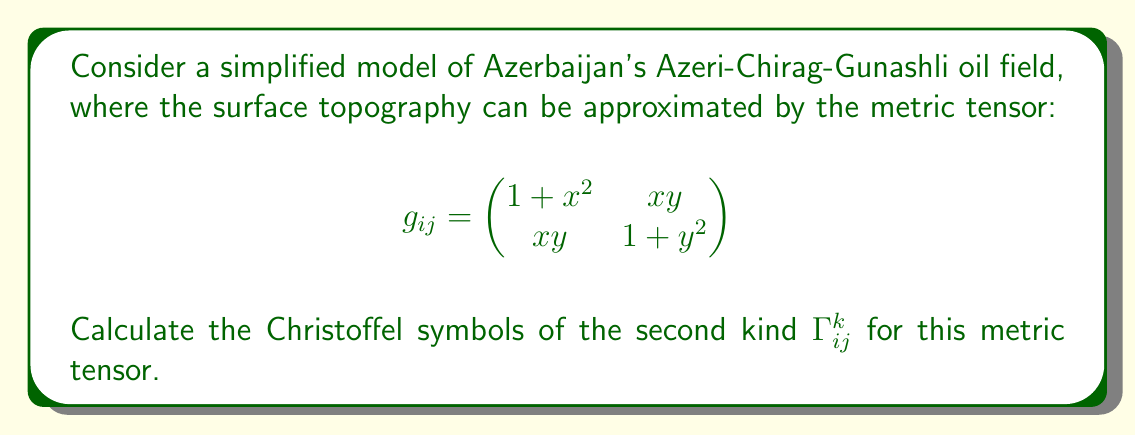Show me your answer to this math problem. To calculate the Christoffel symbols, we'll follow these steps:

1) First, we need to find the inverse metric tensor $g^{ij}$:

$$g^{ij} = \frac{1}{det(g_{ij})} \begin{pmatrix}
1 + y^2 & -xy \\
-xy & 1 + x^2
\end{pmatrix}$$

where $det(g_{ij}) = (1+x^2)(1+y^2) - x^2y^2 = 1 + x^2 + y^2$

2) The Christoffel symbols of the second kind are given by:

$$\Gamma^k_{ij} = \frac{1}{2}g^{km}(\partial_i g_{jm} + \partial_j g_{im} - \partial_m g_{ij})$$

3) Let's calculate each partial derivative:

$\partial_x g_{11} = 2x$
$\partial_y g_{11} = 0$
$\partial_x g_{12} = \partial_x g_{21} = y$
$\partial_y g_{12} = \partial_y g_{21} = x$
$\partial_x g_{22} = 0$
$\partial_y g_{22} = 2y$

4) Now, we can calculate each Christoffel symbol:

$\Gamma^1_{11} = \frac{1}{2}g^{1m}(2\partial_1 g_{1m}) = \frac{1}{2}(g^{11}(2x) + g^{12}(y)) = \frac{x(1+y^2)-xy^2}{1+x^2+y^2}$

$\Gamma^1_{12} = \Gamma^1_{21} = \frac{1}{2}g^{1m}(\partial_1 g_{2m} + \partial_2 g_{1m}) = \frac{1}{2}(g^{11}y + g^{12}x) = \frac{y(1+y^2)-x^2y}{2(1+x^2+y^2)}$

$\Gamma^1_{22} = \frac{1}{2}g^{1m}(2\partial_2 g_{2m}) = \frac{1}{2}(g^{11}(0) + g^{12}(2y)) = \frac{-xy}{1+x^2+y^2}$

$\Gamma^2_{11} = \frac{1}{2}g^{2m}(2\partial_1 g_{1m}) = \frac{1}{2}(g^{21}(2x) + g^{22}(y)) = \frac{-x^2y}{1+x^2+y^2}$

$\Gamma^2_{12} = \Gamma^2_{21} = \frac{1}{2}g^{2m}(\partial_1 g_{2m} + \partial_2 g_{1m}) = \frac{1}{2}(g^{21}y + g^{22}x) = \frac{x(1+x^2)-x^3}{2(1+x^2+y^2)}$

$\Gamma^2_{22} = \frac{1}{2}g^{2m}(2\partial_2 g_{2m}) = \frac{1}{2}(g^{21}(0) + g^{22}(2y)) = \frac{y(1+x^2)-x^2y}{1+x^2+y^2}$
Answer: $\Gamma^1_{11} = \frac{x(1+y^2)-xy^2}{1+x^2+y^2}$, $\Gamma^1_{12} = \Gamma^1_{21} = \frac{y(1+y^2)-x^2y}{2(1+x^2+y^2)}$, $\Gamma^1_{22} = \frac{-xy}{1+x^2+y^2}$, $\Gamma^2_{11} = \frac{-x^2y}{1+x^2+y^2}$, $\Gamma^2_{12} = \Gamma^2_{21} = \frac{x(1+x^2)-x^3}{2(1+x^2+y^2)}$, $\Gamma^2_{22} = \frac{y(1+x^2)-x^2y}{1+x^2+y^2}$ 